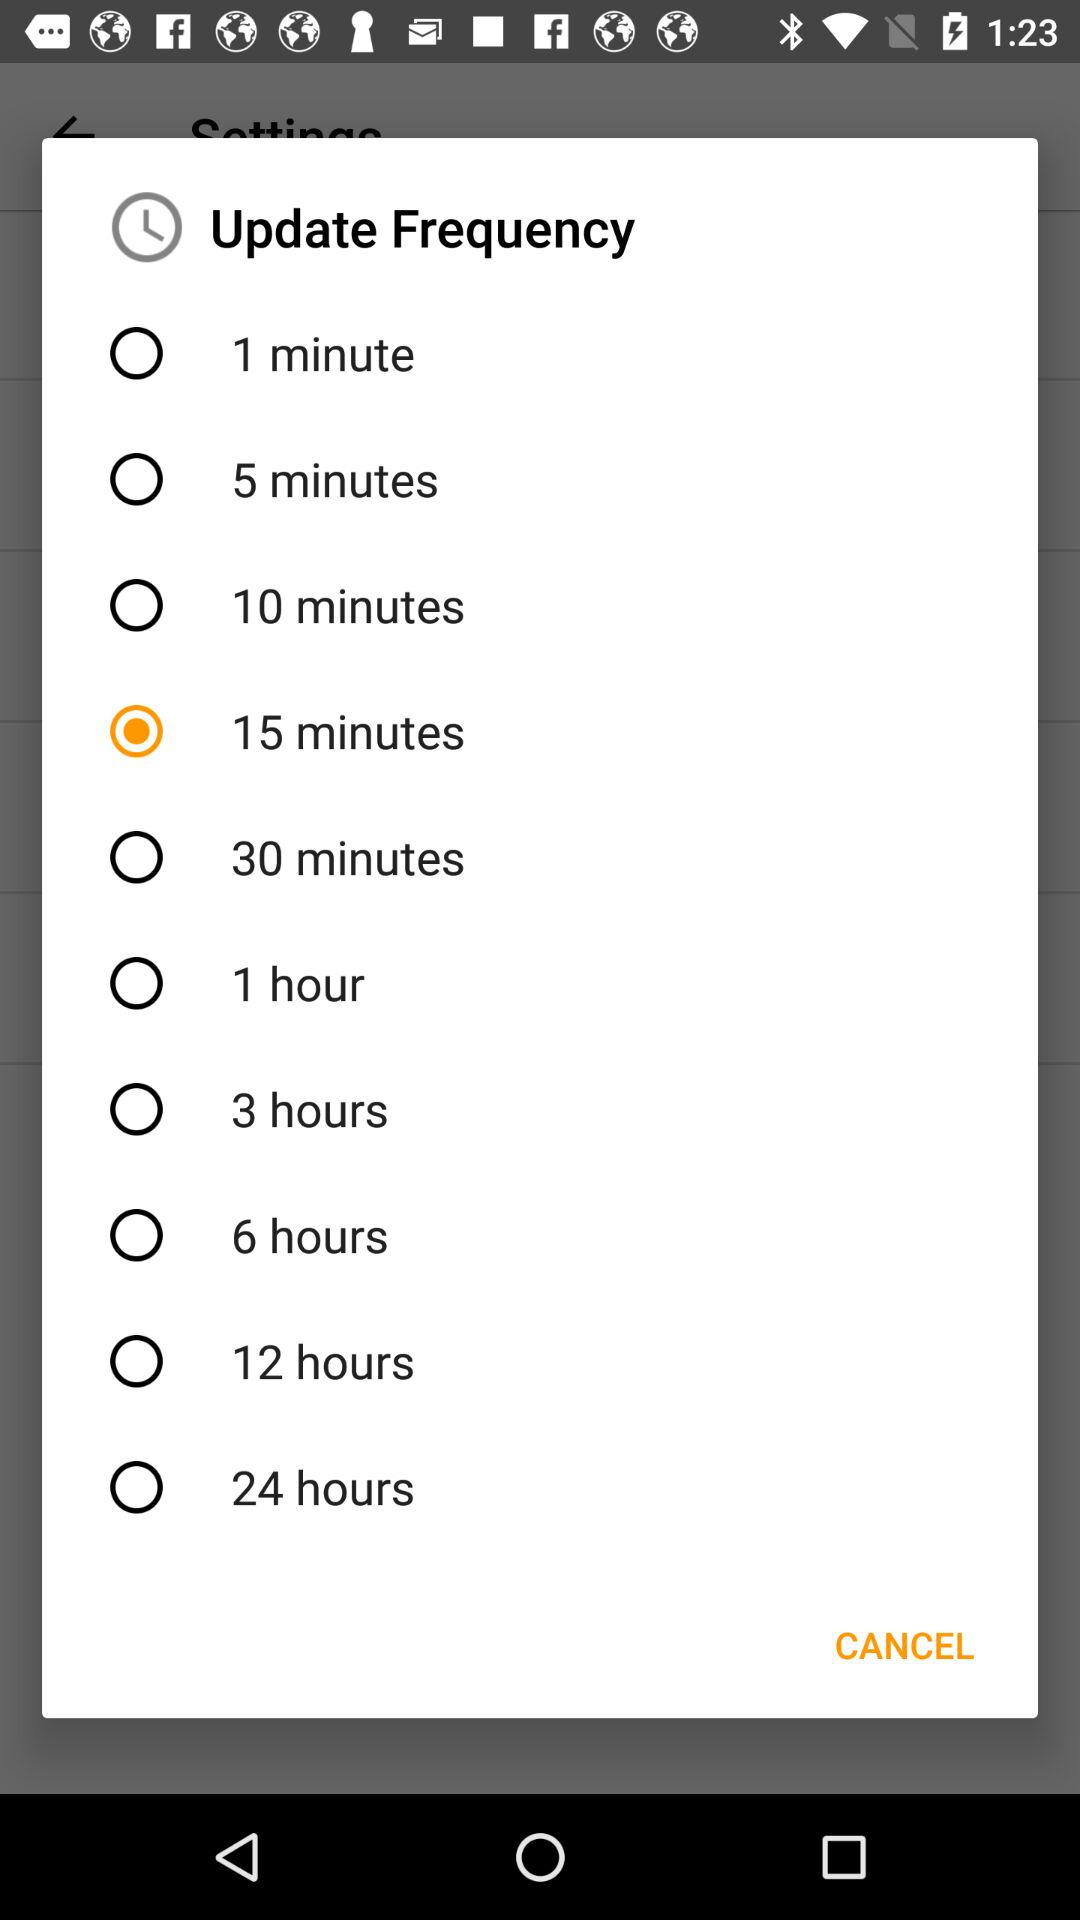How many times more frequent is the update frequency of 1 minute than 1 hour?
Answer the question using a single word or phrase. 60 